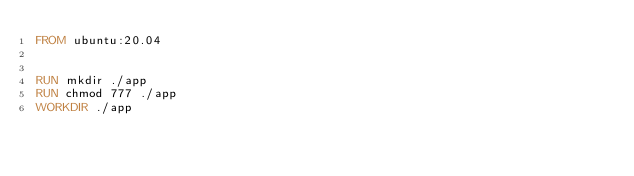Convert code to text. <code><loc_0><loc_0><loc_500><loc_500><_Dockerfile_>FROM ubuntu:20.04


RUN mkdir ./app
RUN chmod 777 ./app
WORKDIR ./app
</code> 